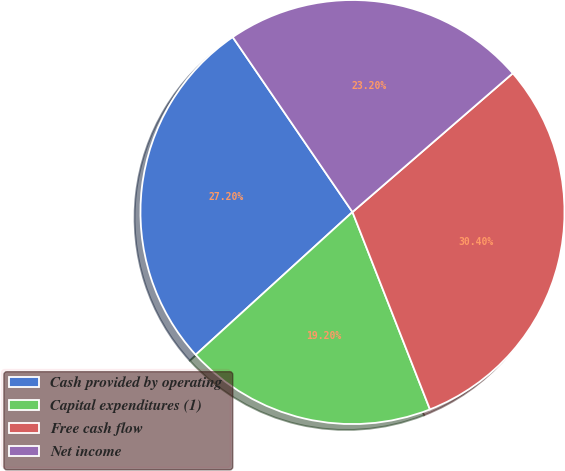<chart> <loc_0><loc_0><loc_500><loc_500><pie_chart><fcel>Cash provided by operating<fcel>Capital expenditures (1)<fcel>Free cash flow<fcel>Net income<nl><fcel>27.2%<fcel>19.2%<fcel>30.4%<fcel>23.2%<nl></chart> 